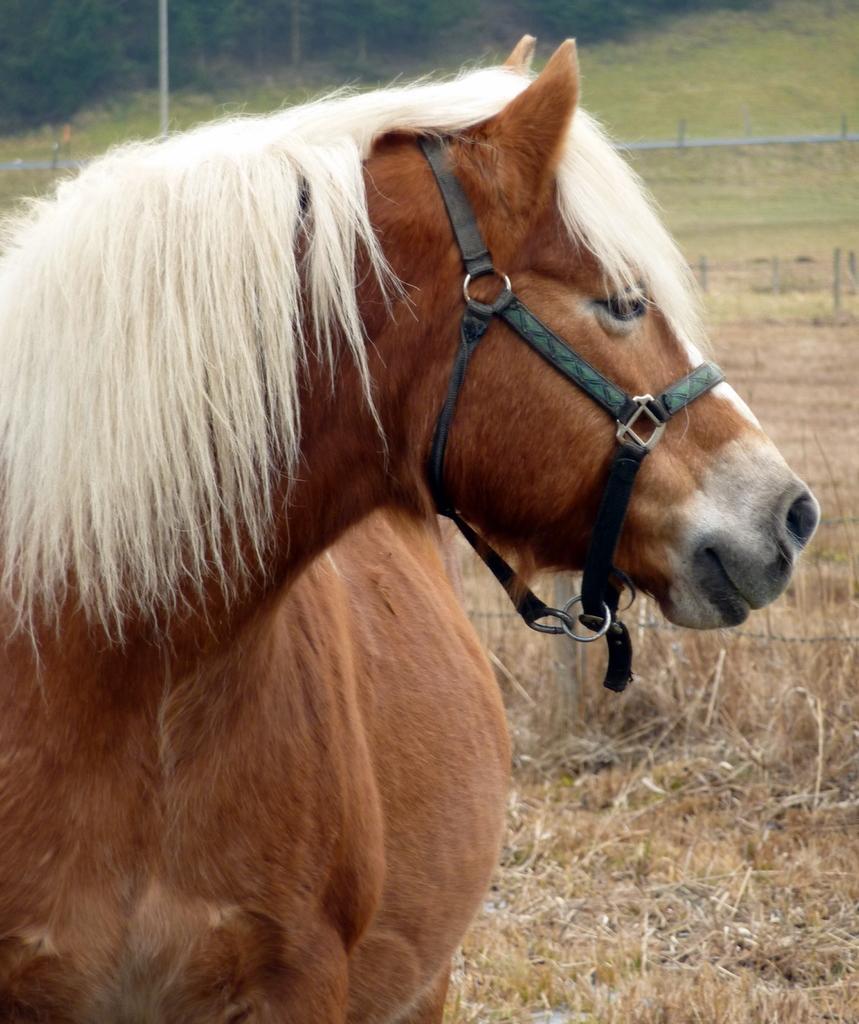In one or two sentences, can you explain what this image depicts? In this image we can see a horse standing on the grass. In the background we can see mesh, poles, ground and trees. 